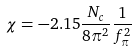<formula> <loc_0><loc_0><loc_500><loc_500>\chi = - 2 . 1 5 \frac { N _ { c } } { 8 \pi ^ { 2 } } \frac { 1 } { f _ { \pi } ^ { 2 } }</formula> 